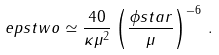Convert formula to latex. <formula><loc_0><loc_0><loc_500><loc_500>\ e p s t w o \simeq \frac { 4 0 } { \kappa \mu ^ { 2 } } \left ( \frac { \phi s t a r } { \mu } \right ) ^ { - 6 } \, .</formula> 